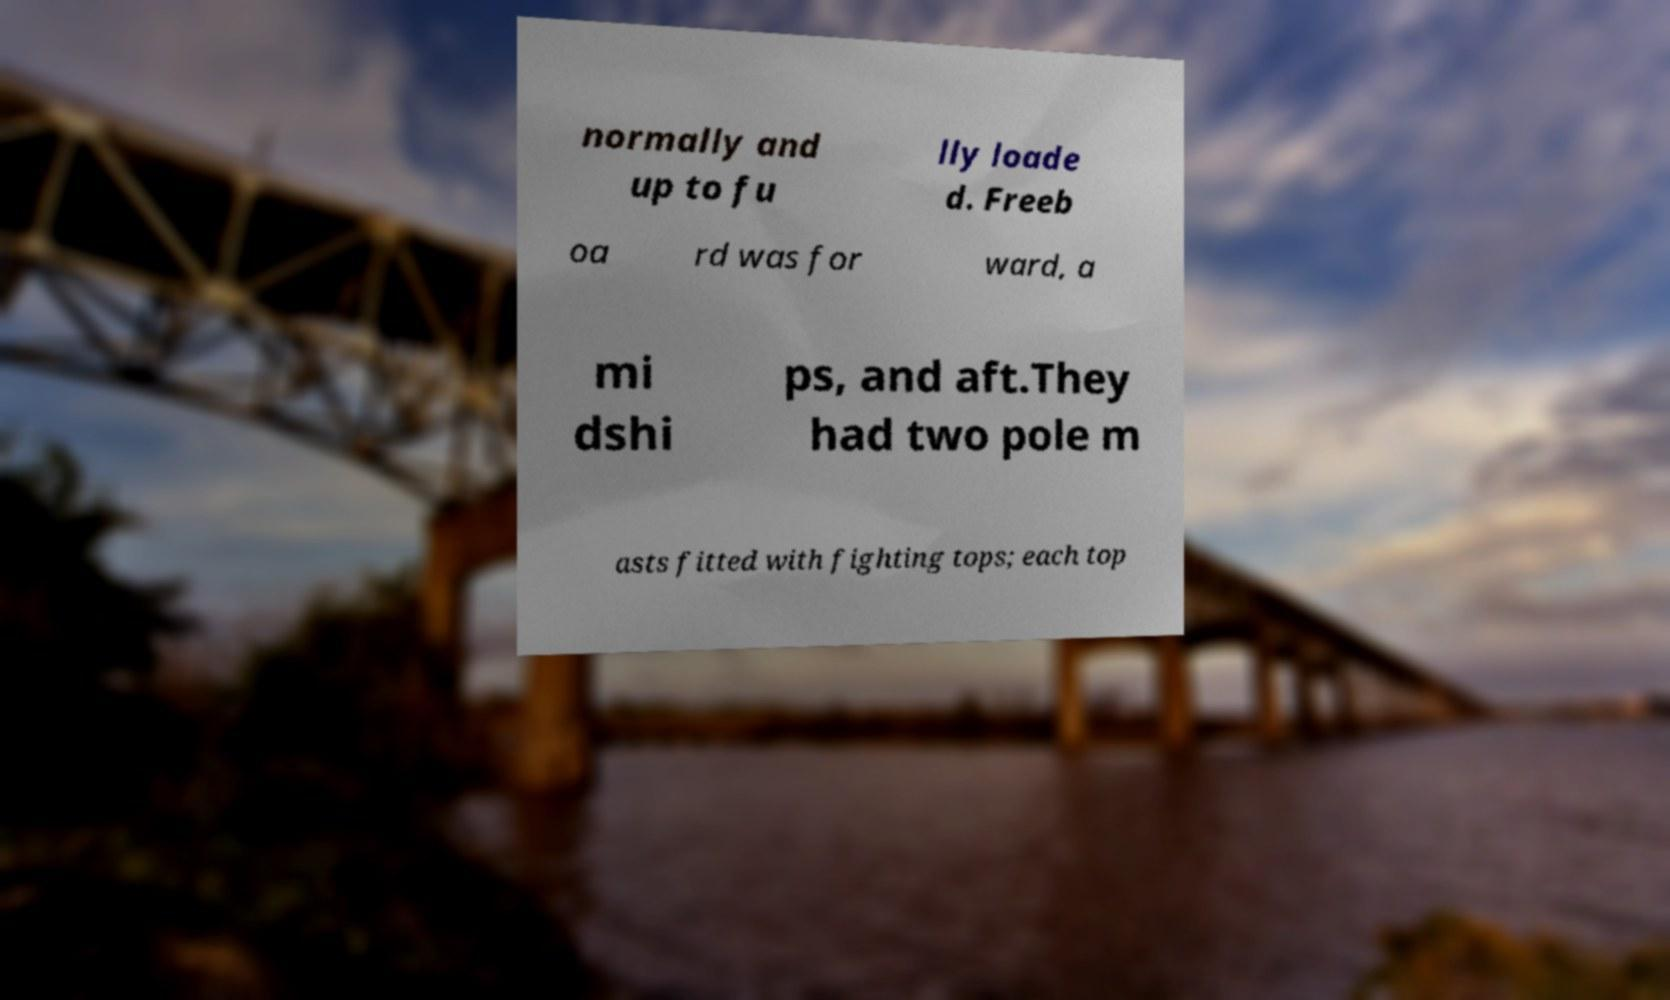Please read and relay the text visible in this image. What does it say? normally and up to fu lly loade d. Freeb oa rd was for ward, a mi dshi ps, and aft.They had two pole m asts fitted with fighting tops; each top 